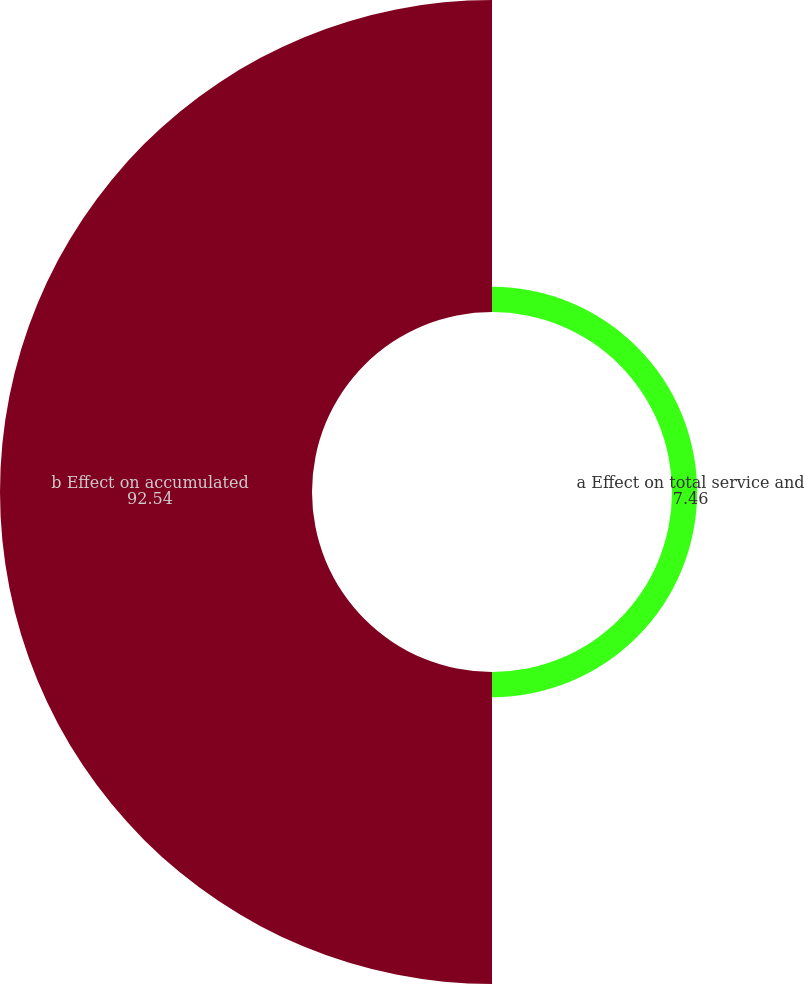<chart> <loc_0><loc_0><loc_500><loc_500><pie_chart><fcel>a Effect on total service and<fcel>b Effect on accumulated<nl><fcel>7.46%<fcel>92.54%<nl></chart> 